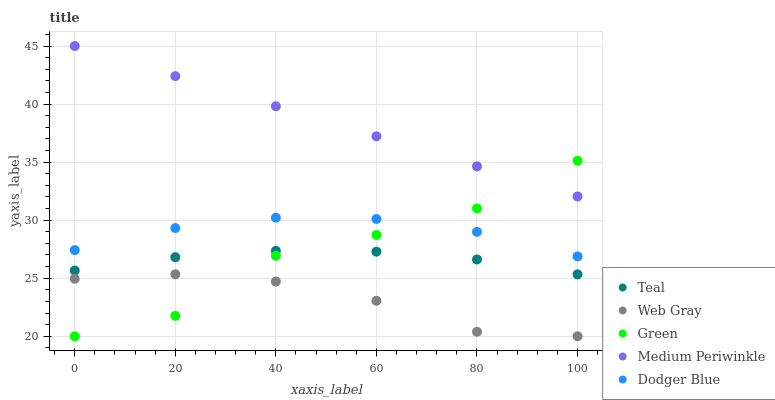Does Web Gray have the minimum area under the curve?
Answer yes or no. Yes. Does Medium Periwinkle have the maximum area under the curve?
Answer yes or no. Yes. Does Green have the minimum area under the curve?
Answer yes or no. No. Does Green have the maximum area under the curve?
Answer yes or no. No. Is Medium Periwinkle the smoothest?
Answer yes or no. Yes. Is Green the roughest?
Answer yes or no. Yes. Is Web Gray the smoothest?
Answer yes or no. No. Is Web Gray the roughest?
Answer yes or no. No. Does Web Gray have the lowest value?
Answer yes or no. Yes. Does Teal have the lowest value?
Answer yes or no. No. Does Medium Periwinkle have the highest value?
Answer yes or no. Yes. Does Green have the highest value?
Answer yes or no. No. Is Web Gray less than Teal?
Answer yes or no. Yes. Is Dodger Blue greater than Teal?
Answer yes or no. Yes. Does Dodger Blue intersect Green?
Answer yes or no. Yes. Is Dodger Blue less than Green?
Answer yes or no. No. Is Dodger Blue greater than Green?
Answer yes or no. No. Does Web Gray intersect Teal?
Answer yes or no. No. 